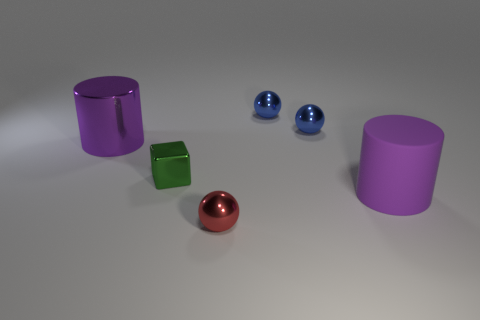Subtract all small red shiny spheres. How many spheres are left? 2 Add 3 large brown objects. How many objects exist? 9 Subtract all red balls. How many balls are left? 2 Add 6 tiny red spheres. How many tiny red spheres exist? 7 Subtract 0 gray balls. How many objects are left? 6 Subtract all blocks. How many objects are left? 5 Subtract 2 spheres. How many spheres are left? 1 Subtract all green spheres. Subtract all blue cylinders. How many spheres are left? 3 Subtract all purple cylinders. How many blue spheres are left? 2 Subtract all red balls. Subtract all tiny purple objects. How many objects are left? 5 